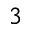Convert formula to latex. <formula><loc_0><loc_0><loc_500><loc_500>^ { 3 }</formula> 